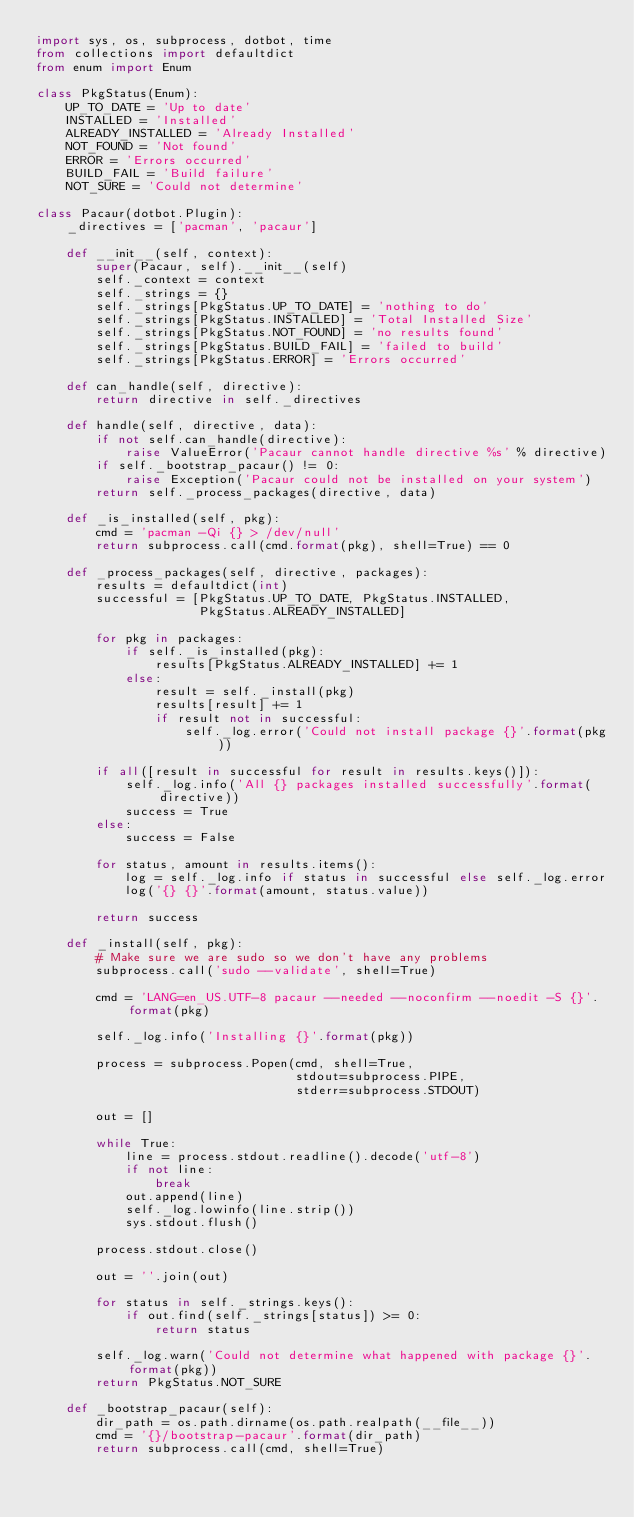Convert code to text. <code><loc_0><loc_0><loc_500><loc_500><_Python_>import sys, os, subprocess, dotbot, time
from collections import defaultdict
from enum import Enum

class PkgStatus(Enum):
    UP_TO_DATE = 'Up to date'
    INSTALLED = 'Installed'
    ALREADY_INSTALLED = 'Already Installed'
    NOT_FOUND = 'Not found'
    ERROR = 'Errors occurred'
    BUILD_FAIL = 'Build failure'
    NOT_SURE = 'Could not determine'

class Pacaur(dotbot.Plugin):
    _directives = ['pacman', 'pacaur']

    def __init__(self, context):
        super(Pacaur, self).__init__(self)
        self._context = context
        self._strings = {}
        self._strings[PkgStatus.UP_TO_DATE] = 'nothing to do'
        self._strings[PkgStatus.INSTALLED] = 'Total Installed Size'
        self._strings[PkgStatus.NOT_FOUND] = 'no results found'
        self._strings[PkgStatus.BUILD_FAIL] = 'failed to build'
        self._strings[PkgStatus.ERROR] = 'Errors occurred'

    def can_handle(self, directive):
        return directive in self._directives

    def handle(self, directive, data):
        if not self.can_handle(directive):
            raise ValueError('Pacaur cannot handle directive %s' % directive)
        if self._bootstrap_pacaur() != 0:
            raise Exception('Pacaur could not be installed on your system')
        return self._process_packages(directive, data)

    def _is_installed(self, pkg):
        cmd = 'pacman -Qi {} > /dev/null'
        return subprocess.call(cmd.format(pkg), shell=True) == 0

    def _process_packages(self, directive, packages):
        results = defaultdict(int)
        successful = [PkgStatus.UP_TO_DATE, PkgStatus.INSTALLED,
                      PkgStatus.ALREADY_INSTALLED]

        for pkg in packages:
            if self._is_installed(pkg):
                results[PkgStatus.ALREADY_INSTALLED] += 1
            else:
                result = self._install(pkg)
                results[result] += 1
                if result not in successful:
                    self._log.error('Could not install package {}'.format(pkg))

        if all([result in successful for result in results.keys()]):
            self._log.info('All {} packages installed successfully'.format(directive))
            success = True
        else:
            success = False

        for status, amount in results.items():
            log = self._log.info if status in successful else self._log.error
            log('{} {}'.format(amount, status.value))

        return success

    def _install(self, pkg):
        # Make sure we are sudo so we don't have any problems
        subprocess.call('sudo --validate', shell=True)

        cmd = 'LANG=en_US.UTF-8 pacaur --needed --noconfirm --noedit -S {}'.format(pkg)

        self._log.info('Installing {}'.format(pkg))

        process = subprocess.Popen(cmd, shell=True,
                                   stdout=subprocess.PIPE,
                                   stderr=subprocess.STDOUT)

        out = []

        while True:
            line = process.stdout.readline().decode('utf-8')
            if not line:
                break
            out.append(line)
            self._log.lowinfo(line.strip())
            sys.stdout.flush()

        process.stdout.close()

        out = ''.join(out)

        for status in self._strings.keys():
            if out.find(self._strings[status]) >= 0:
                return status

        self._log.warn('Could not determine what happened with package {}'.format(pkg))
        return PkgStatus.NOT_SURE

    def _bootstrap_pacaur(self):
        dir_path = os.path.dirname(os.path.realpath(__file__))
        cmd = '{}/bootstrap-pacaur'.format(dir_path)
        return subprocess.call(cmd, shell=True)
</code> 